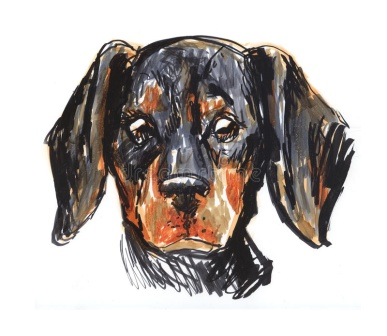Imagine if the illustration of the puppy was magically brought to life. What kind of magical powers might this puppy have? If this illustration of the puppy were brought to life with magical powers, it could possess the ability to heal with a touch of its paw. Its empathetic eyes might allow it to sense emotions and bring comfort to those in distress. With a gentle bark, it could summon a warm, glowing light that soothes any sadness or fear. Additionally, this extraordinary puppy might have the power to communicate with other animals, fostering harmony and understanding in its surroundings. Imagine it scampering through the streets, leaving a trail of magic that blooms flowers and creates a sense of peace wherever it goes. Consider the puppy’s expression. What might be the backstory that led to this particular moment captured in the illustration? The puppy, named Milo, had a day unlike any other. Earlier that morning, he had been exploring the neighborhood park when he spotted a small kitten stuck on a tree branch, meowing for help. With a brave heart, Milo barked for assistance, drawing the attention of a passerby who helped rescue the kitten. The two became instant friends, spending the day playing and sharing treats. But as the sun began to set, the time came for them to part ways. The expression captured in the illustration shows Milo in that bittersweet moment of saying goodbye to his new friend, his eyes reflecting both the joy of their shared adventure and the sorrow of their separation. Milo's bittersweet look is a reminder of fleeting yet precious moments of friendship and bravery. 